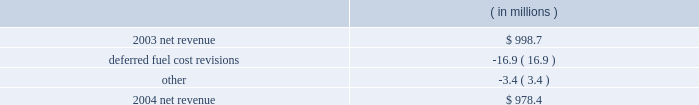Entergy arkansas , inc .
Management's financial discussion and analysis results of operations net income 2004 compared to 2003 net income increased $ 16.2 million due to lower other operation and maintenance expenses , a lower effective income tax rate for 2004 compared to 2003 , and lower interest charges .
The increase was partially offset by lower net revenue .
2003 compared to 2002 net income decreased $ 9.6 million due to lower net revenue , higher depreciation and amortization expenses , and a higher effective income tax rate for 2003 compared to 2002 .
The decrease was substantially offset by lower other operation and maintenance expenses , higher other income , and lower interest charges .
Net revenue 2004 compared to 2003 net revenue , which is entergy arkansas' measure of gross margin , consists of operating revenues net of : 1 ) fuel , fuel-related , and purchased power expenses and 2 ) other regulatory credits .
Following is an analysis of the change in net revenue comparing 2004 to 2003. .
Deferred fuel cost revisions includes the difference between the estimated deferred fuel expense and the actual calculation of recoverable fuel expense , which occurs on an annual basis .
Deferred fuel cost revisions decreased net revenue due to a revised estimate of fuel costs filed for recovery at entergy arkansas in the march 2004 energy cost recovery rider , which reduced net revenue by $ 11.5 million .
The remainder of the variance is due to the 2002 energy cost recovery true-up , made in the first quarter of 2003 , which increased net revenue in 2003 .
Gross operating revenues , fuel and purchased power expenses , and other regulatory credits gross operating revenues increased primarily due to : 2022 an increase of $ 20.7 million in fuel cost recovery revenues due to an increase in the energy cost recovery rider effective april 2004 ( fuel cost recovery revenues are discussed in note 2 to the domestic utility companies and system energy financial statements ) ; 2022 an increase of $ 15.5 million in grand gulf revenues due to an increase in the grand gulf rider effective january 2004 ; 2022 an increase of $ 13.9 million in gross wholesale revenue primarily due to increased sales to affiliated systems ; 2022 an increase of $ 9.5 million due to volume/weather primarily resulting from increased usage during the unbilled sales period , partially offset by the effect of milder weather on billed sales in 2004. .
What is the growth rate in net revenue in 2004 for entergy arkansas inc.? 
Computations: ((978.4 - 998.7) / 998.7)
Answer: -0.02033. 